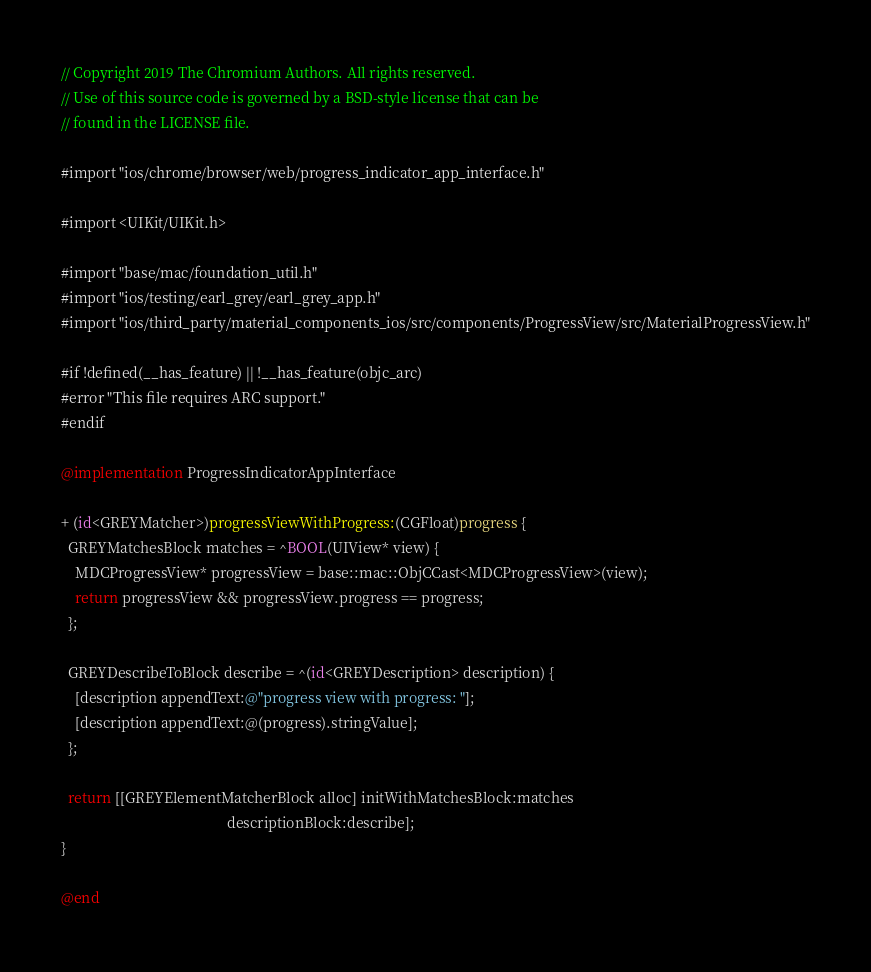Convert code to text. <code><loc_0><loc_0><loc_500><loc_500><_ObjectiveC_>// Copyright 2019 The Chromium Authors. All rights reserved.
// Use of this source code is governed by a BSD-style license that can be
// found in the LICENSE file.

#import "ios/chrome/browser/web/progress_indicator_app_interface.h"

#import <UIKit/UIKit.h>

#import "base/mac/foundation_util.h"
#import "ios/testing/earl_grey/earl_grey_app.h"
#import "ios/third_party/material_components_ios/src/components/ProgressView/src/MaterialProgressView.h"

#if !defined(__has_feature) || !__has_feature(objc_arc)
#error "This file requires ARC support."
#endif

@implementation ProgressIndicatorAppInterface

+ (id<GREYMatcher>)progressViewWithProgress:(CGFloat)progress {
  GREYMatchesBlock matches = ^BOOL(UIView* view) {
    MDCProgressView* progressView = base::mac::ObjCCast<MDCProgressView>(view);
    return progressView && progressView.progress == progress;
  };

  GREYDescribeToBlock describe = ^(id<GREYDescription> description) {
    [description appendText:@"progress view with progress: "];
    [description appendText:@(progress).stringValue];
  };

  return [[GREYElementMatcherBlock alloc] initWithMatchesBlock:matches
                                              descriptionBlock:describe];
}

@end
</code> 